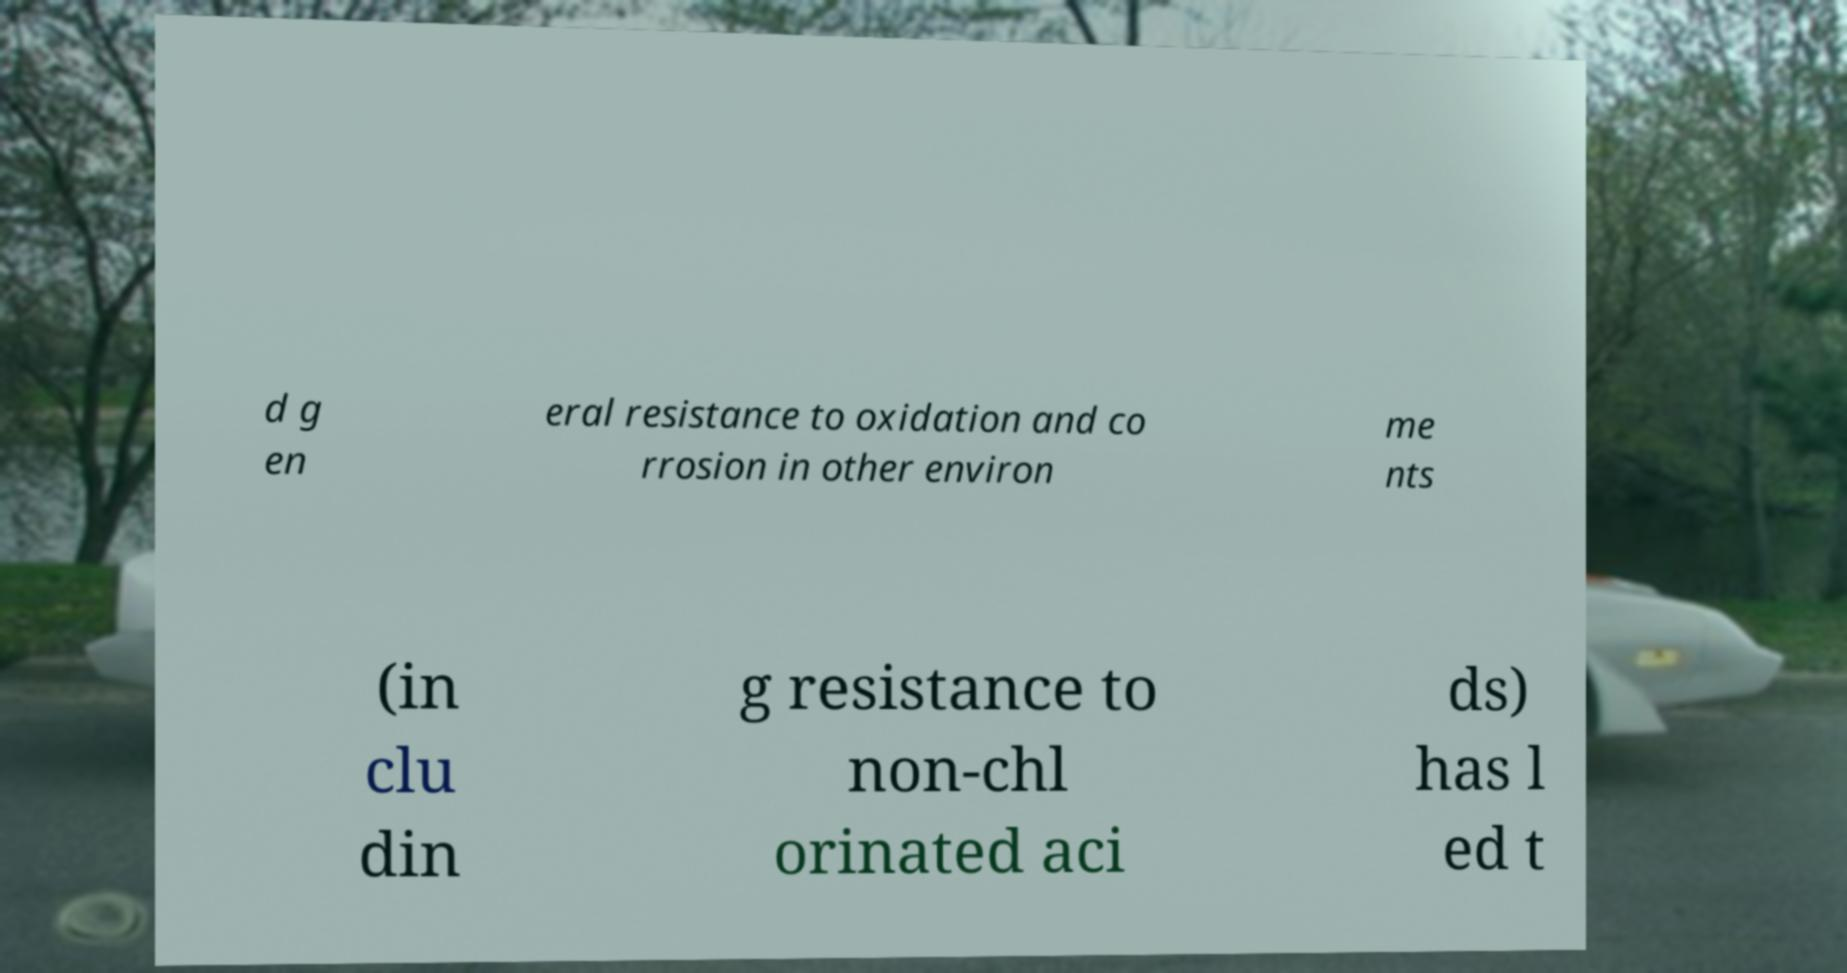There's text embedded in this image that I need extracted. Can you transcribe it verbatim? d g en eral resistance to oxidation and co rrosion in other environ me nts (in clu din g resistance to non-chl orinated aci ds) has l ed t 